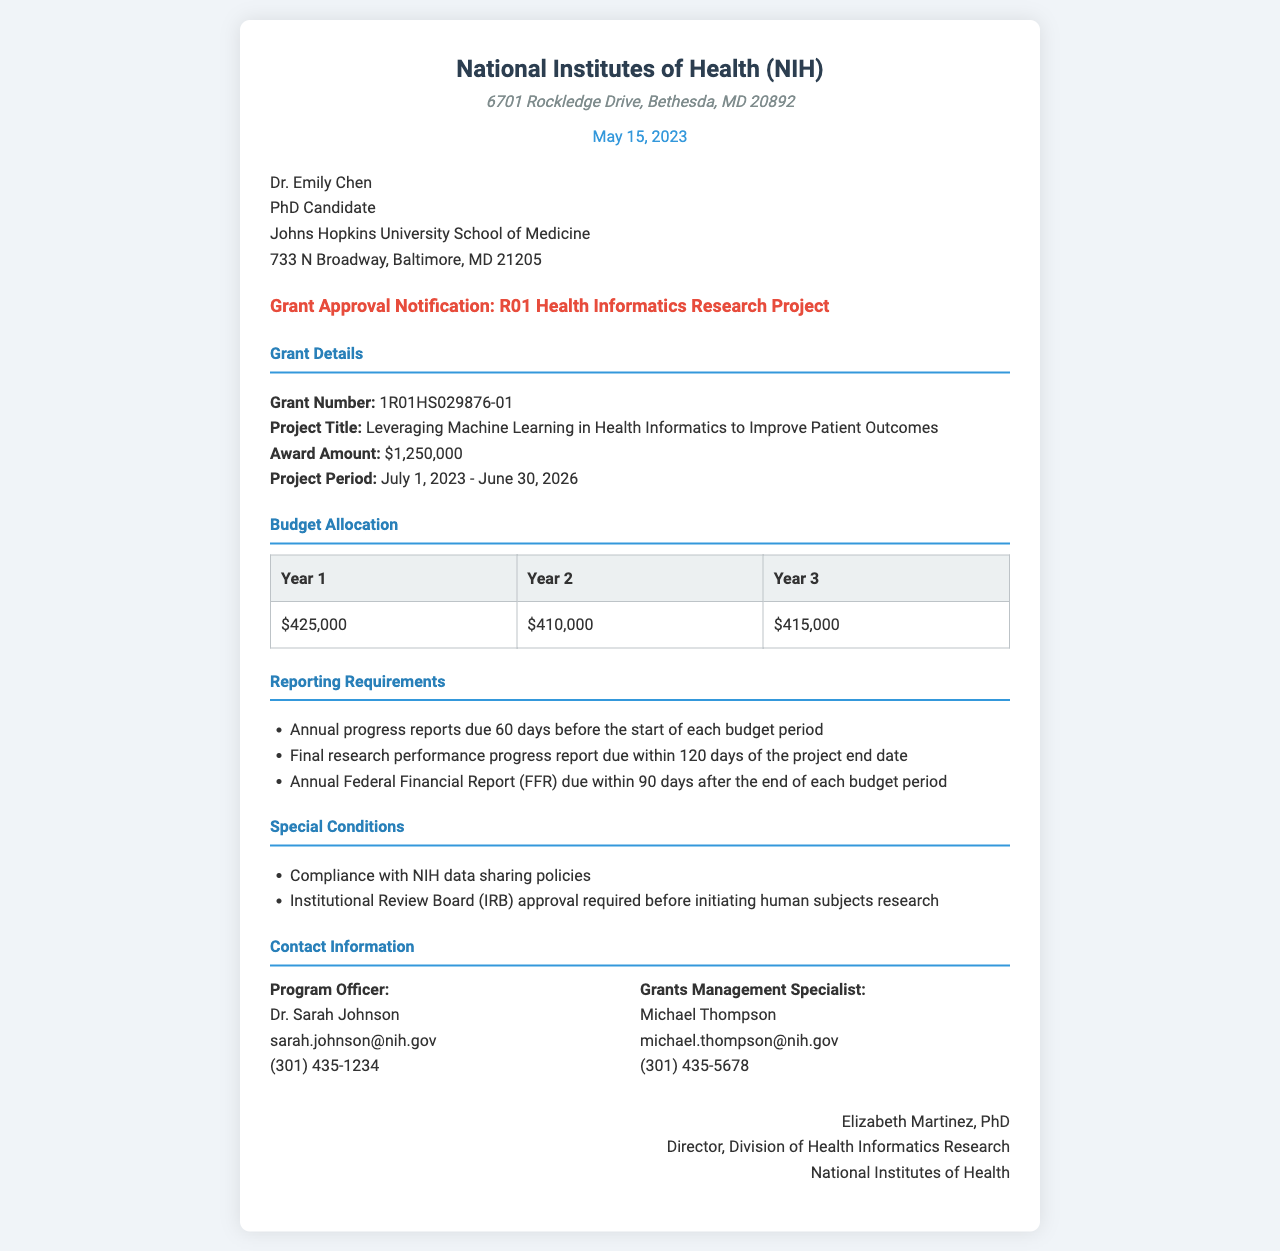What is the grant number? The grant number is listed in the Grant Details section of the document.
Answer: 1R01HS029876-01 What is the award amount? The award amount is provided in the Grant Details section.
Answer: $1,250,000 When is the project period? The project period is stated in the Grant Details section of the document.
Answer: July 1, 2023 - June 30, 2026 How much is allocated for Year 1? The budget allocation for Year 1 is specified in the Budget Allocation section.
Answer: $425,000 What is required before initiating human subjects research? This condition is specified in the Special Conditions section.
Answer: Institutional Review Board (IRB) approval When are the annual progress reports due? The deadline for the annual progress reports is detailed in the Reporting Requirements section.
Answer: 60 days before the start of each budget period Who is the Program Officer? The Program Officer's name is mentioned in the Contact Information section.
Answer: Dr. Sarah Johnson What is the fax date? The date the document was prepared is indicated prominently at the top of the document.
Answer: May 15, 2023 